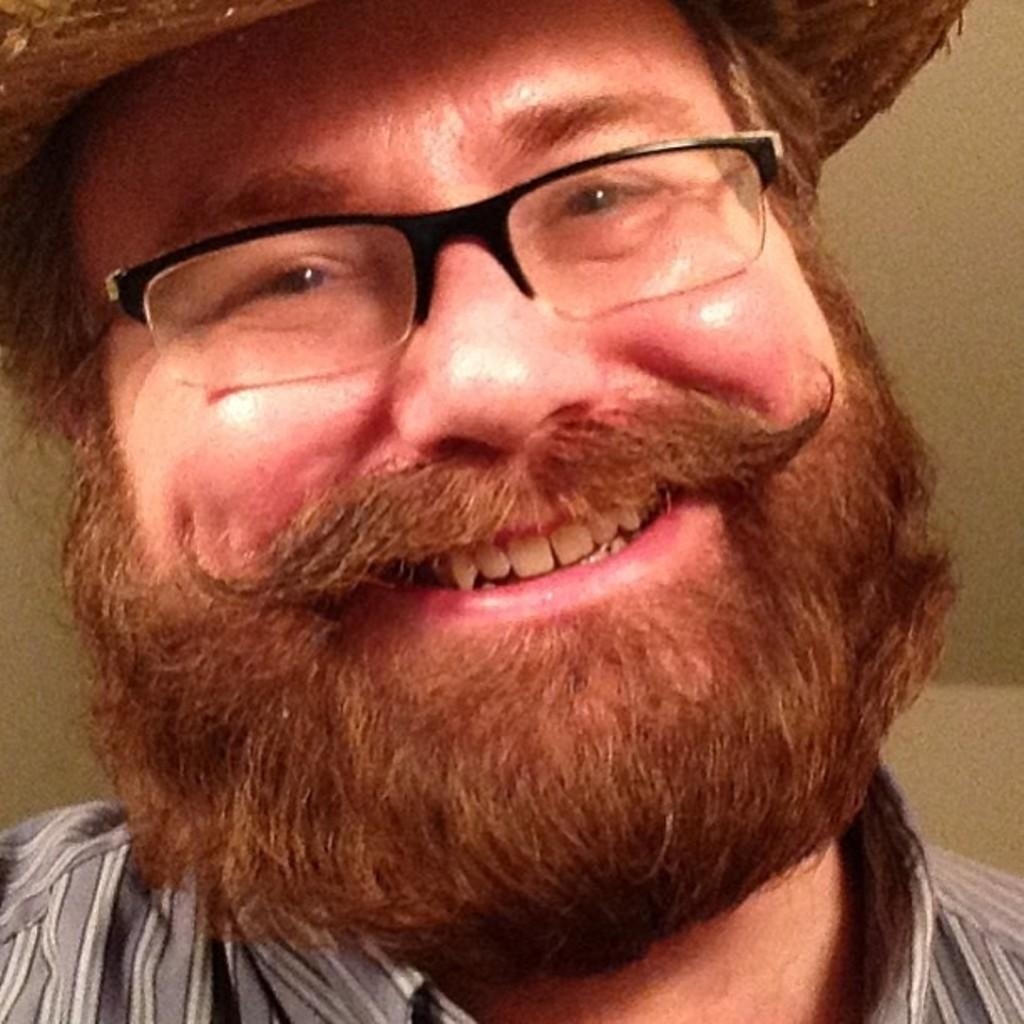What is present in the image? There is a man in the image. What can be observed about the man's appearance? The man is wearing glasses (specs). What is the man's facial expression in the image? The man is smiling. How many trees are visible behind the man in the image? There are no trees visible in the image; it only features a man wearing glasses and smiling. 